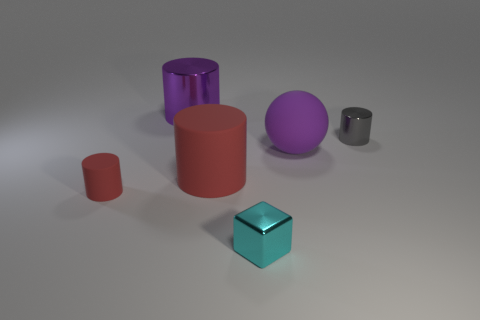Add 4 big purple metal objects. How many objects exist? 10 Subtract all blocks. How many objects are left? 5 Add 4 matte cylinders. How many matte cylinders are left? 6 Add 2 red rubber cylinders. How many red rubber cylinders exist? 4 Subtract 1 gray cylinders. How many objects are left? 5 Subtract all small metallic cylinders. Subtract all big purple objects. How many objects are left? 3 